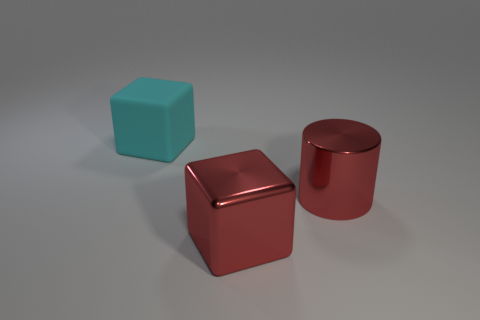Are there any other things that have the same material as the cyan block?
Make the answer very short. No. Is the color of the big shiny block the same as the block on the left side of the large metal cube?
Make the answer very short. No. Is the number of metal cylinders less than the number of cyan metal things?
Offer a very short reply. No. Is the number of large rubber objects behind the rubber cube greater than the number of objects that are behind the large cylinder?
Make the answer very short. No. Does the big cyan block have the same material as the cylinder?
Offer a terse response. No. There is a large object on the left side of the red shiny cube; how many large things are in front of it?
Keep it short and to the point. 2. Do the large shiny object behind the metallic block and the shiny cube have the same color?
Your response must be concise. Yes. What number of things are red blocks or things that are behind the large metal cube?
Provide a succinct answer. 3. Does the large red thing that is in front of the big metal cylinder have the same shape as the cyan rubber thing left of the large red cube?
Provide a short and direct response. Yes. Are there any other things of the same color as the metallic cube?
Ensure brevity in your answer.  Yes. 